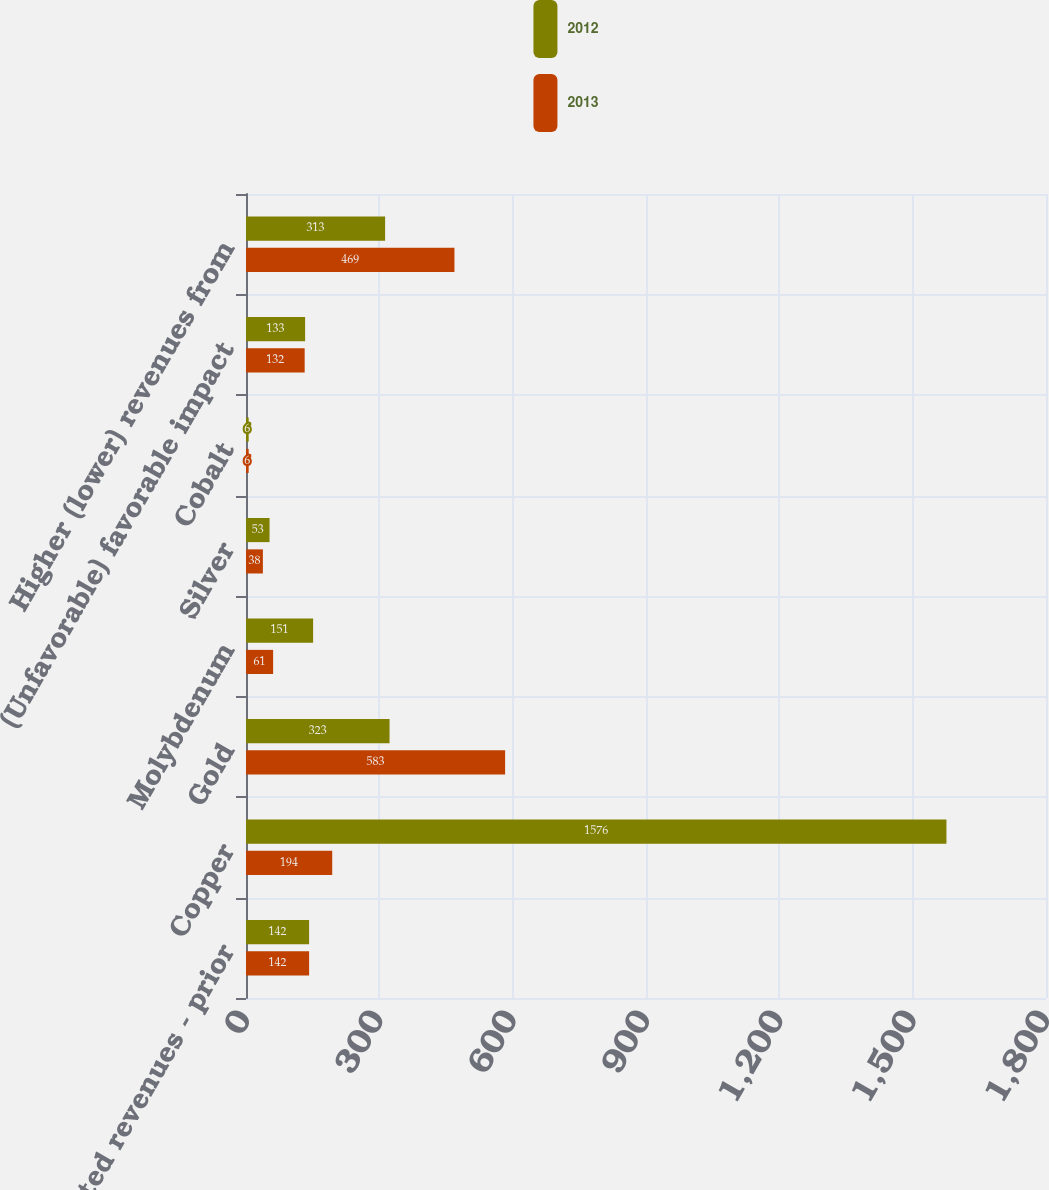Convert chart. <chart><loc_0><loc_0><loc_500><loc_500><stacked_bar_chart><ecel><fcel>Consolidated revenues - prior<fcel>Copper<fcel>Gold<fcel>Molybdenum<fcel>Silver<fcel>Cobalt<fcel>(Unfavorable) favorable impact<fcel>Higher (lower) revenues from<nl><fcel>2012<fcel>142<fcel>1576<fcel>323<fcel>151<fcel>53<fcel>6<fcel>133<fcel>313<nl><fcel>2013<fcel>142<fcel>194<fcel>583<fcel>61<fcel>38<fcel>6<fcel>132<fcel>469<nl></chart> 